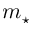<formula> <loc_0><loc_0><loc_500><loc_500>m _ { ^ { * } }</formula> 